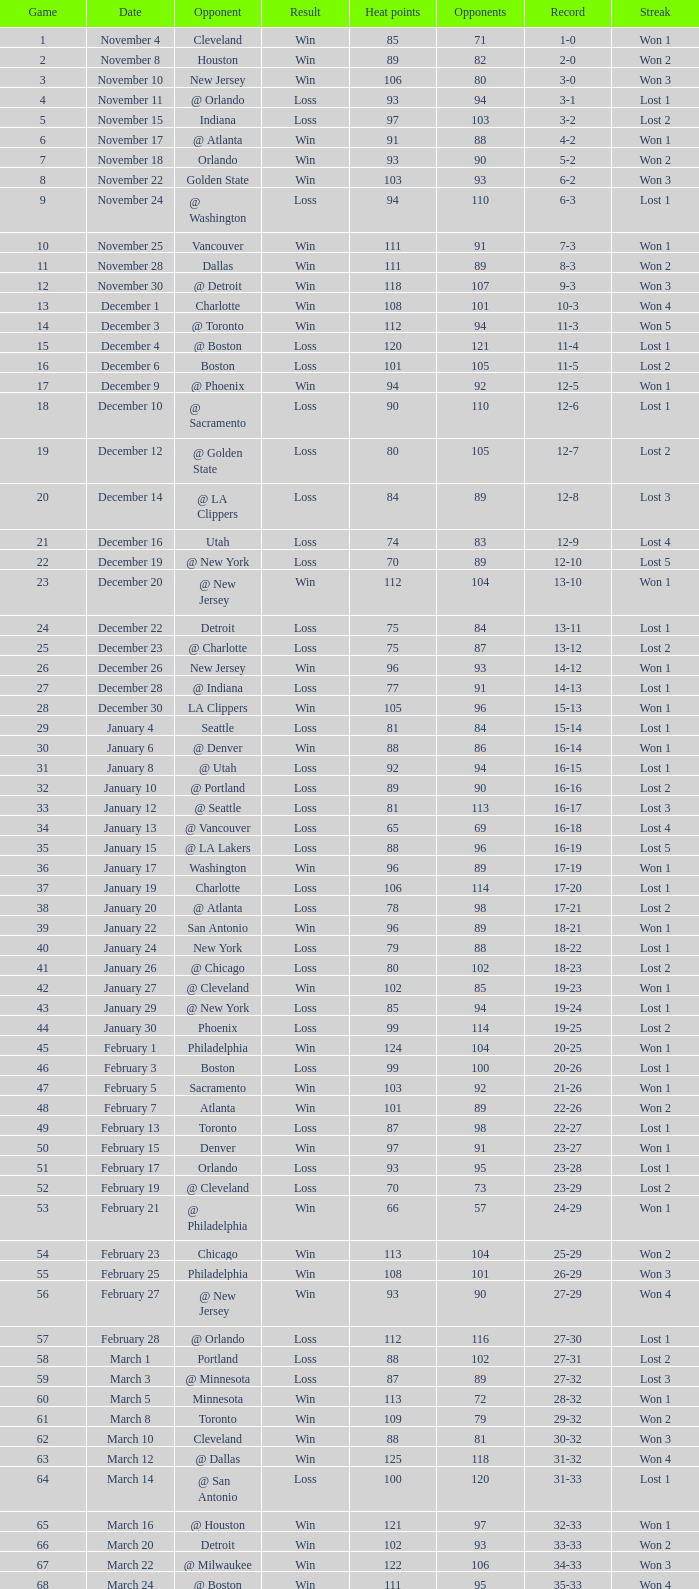What is Heat Points, when Game is less than 80, and when Date is "April 26 (First Round)"? 85.0. 